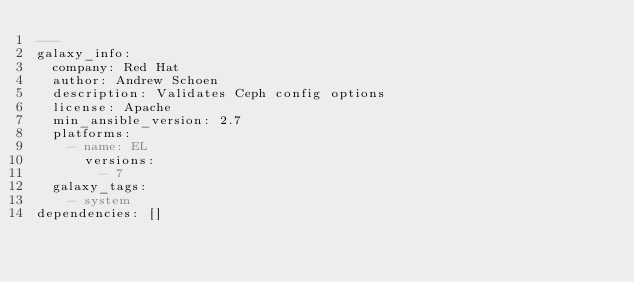Convert code to text. <code><loc_0><loc_0><loc_500><loc_500><_YAML_>---
galaxy_info:
  company: Red Hat
  author: Andrew Schoen
  description: Validates Ceph config options
  license: Apache
  min_ansible_version: 2.7
  platforms:
    - name: EL
      versions:
        - 7
  galaxy_tags:
    - system
dependencies: []
</code> 